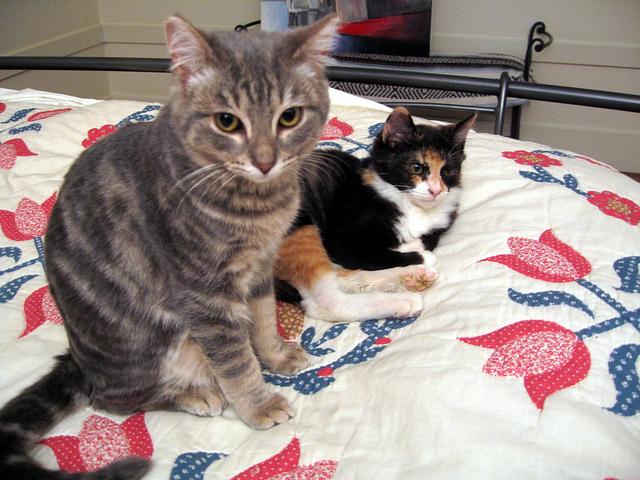What fur patterns does each cat have?
Write a very short answer. Calico. Does this cat have blue eyes?
Short answer required. No. Are both cats laying down?
Answer briefly. No. Are the cats the same color?
Short answer required. No. 